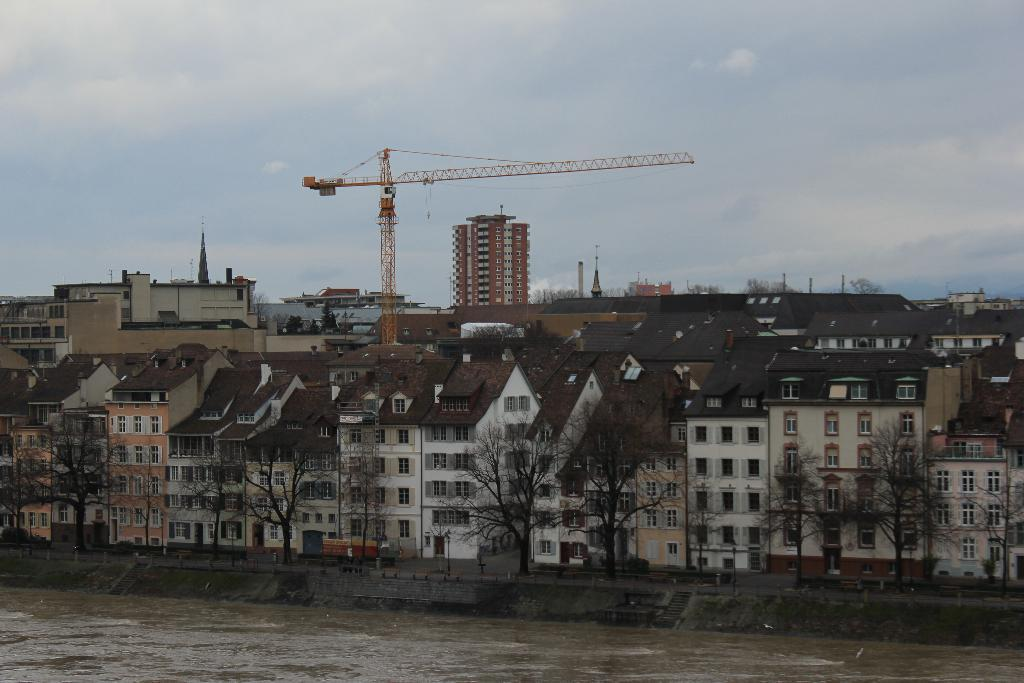What is one of the main elements in the image? There is water in the image. What else can be seen in the image besides water? There is a road, benches, trash bins, trees, buildings, and a construction crane in the image. What is the condition of the sky in the image? The sky is visible in the image, and there are clouds present. Can you describe the type of structures in the image? There are buildings in the image, and one of them is a construction crane. What type of pie is being served on the benches in the image? There is no pie present in the image; the benches are empty. How does the wind affect the clouds in the image? The image does not show the wind's effect on the clouds, as it only depicts the clouds' static appearance. 